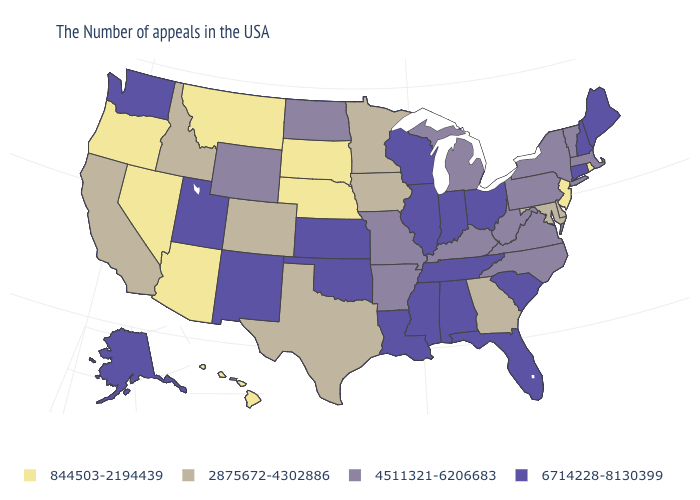Does North Carolina have a lower value than Hawaii?
Quick response, please. No. What is the value of Wyoming?
Quick response, please. 4511321-6206683. Name the states that have a value in the range 844503-2194439?
Concise answer only. Rhode Island, New Jersey, Nebraska, South Dakota, Montana, Arizona, Nevada, Oregon, Hawaii. Among the states that border Wyoming , does Montana have the lowest value?
Concise answer only. Yes. Which states hav the highest value in the MidWest?
Answer briefly. Ohio, Indiana, Wisconsin, Illinois, Kansas. Which states have the lowest value in the USA?
Give a very brief answer. Rhode Island, New Jersey, Nebraska, South Dakota, Montana, Arizona, Nevada, Oregon, Hawaii. What is the value of Hawaii?
Give a very brief answer. 844503-2194439. Does Minnesota have the highest value in the USA?
Quick response, please. No. What is the highest value in the Northeast ?
Short answer required. 6714228-8130399. Among the states that border Ohio , does West Virginia have the highest value?
Keep it brief. No. What is the lowest value in the USA?
Answer briefly. 844503-2194439. Which states have the highest value in the USA?
Quick response, please. Maine, New Hampshire, Connecticut, South Carolina, Ohio, Florida, Indiana, Alabama, Tennessee, Wisconsin, Illinois, Mississippi, Louisiana, Kansas, Oklahoma, New Mexico, Utah, Washington, Alaska. What is the highest value in states that border Missouri?
Answer briefly. 6714228-8130399. Among the states that border Ohio , does Indiana have the lowest value?
Answer briefly. No. Name the states that have a value in the range 6714228-8130399?
Concise answer only. Maine, New Hampshire, Connecticut, South Carolina, Ohio, Florida, Indiana, Alabama, Tennessee, Wisconsin, Illinois, Mississippi, Louisiana, Kansas, Oklahoma, New Mexico, Utah, Washington, Alaska. 